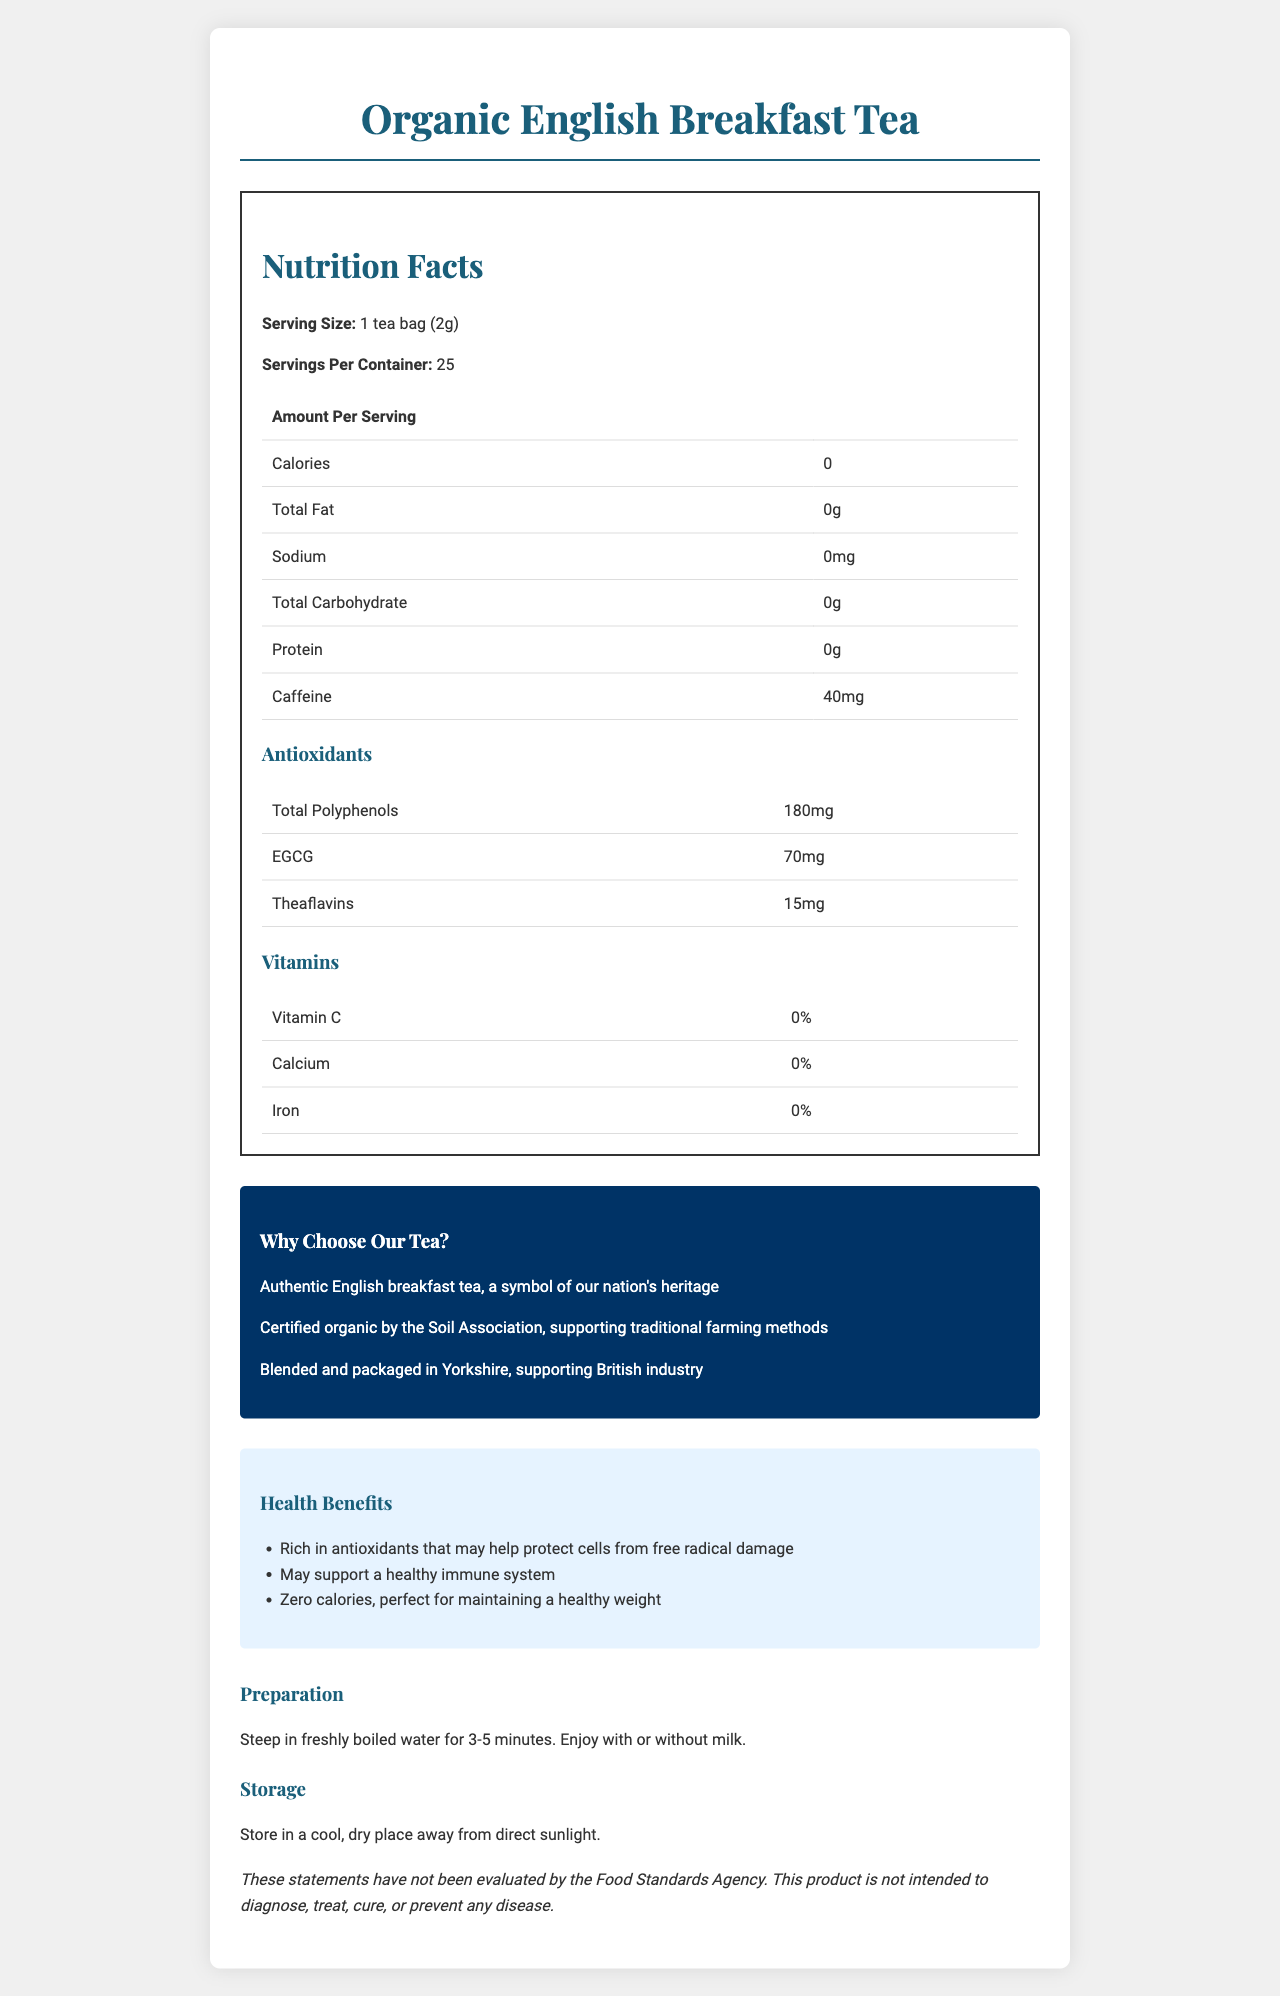what is the serving size for the Organic English Breakfast Tea? The document states that the serving size for the Organic English Breakfast Tea is 1 tea bag (2g).
Answer: 1 tea bag (2g) how many servings are there per container? The document shows that there are 25 servings per container.
Answer: 25 how many calories are there per serving? The nutrition facts panel indicates that each serving has 0 calories.
Answer: 0 what are the antioxidant contents of a serving of this tea? The document lists the antioxidants as Total Polyphenols: 180mg, EGCG: 70mg, Theaflavins: 15mg.
Answer: Total Polyphenols: 180mg, EGCG: 70mg, Theaflavins: 15mg how much caffeine does each serving contain? The document specifies that each serving contains 40mg of caffeine.
Answer: 40mg what is the main ingredient of the Organic English Breakfast Tea? A. Organic black tea leaves from Assam, India B. Green tea leaves C. Herbal blend The document clearly states that the main ingredient is Organic black tea leaves from Assam, India.
Answer: A which vitamin is present in the Organic English Breakfast Tea? A. Vitamin C B. Vitamin D C. Vitamin E D. None The vitamins section in the document indicates that there is 0% Vitamin C, Calcium, and Iron, meaning no vitamins are present.
Answer: D does this tea have any sodium content? The nutrition facts section states that the sodium content is 0mg, which means there is no sodium.
Answer: No why might someone choose this Organic English Breakfast Tea according to the conservative appeal attributes? The conservative appeal section emphasizes British tradition, organic certification by the Soil Association, and local production in Yorkshire as reasons to choose this tea.
Answer: Someone might choose it because it is an authentic symbol of British tradition, is certified organic supporting traditional farming methods, and is blended and packaged in Yorkshire, supporting British industry. what is claimed about the health benefits of this tea? The health claims section lists these three health benefits.
Answer: It is rich in antioxidants that may help protect cells from free radical damage, may support a healthy immune system, and has zero calories which is perfect for maintaining a healthy weight. summarize the main idea of the document. The document contains comprehensive nutrition information, highlights the tea's antioxidant content, underscores its support for British tradition and industry, promotes its health benefits, and gives preparation and storage instructions.
Answer: The document provides detailed information on the nutrition facts, antioxidant properties, ingredients, conservative appeal, health benefits, preparation, and storage instructions for Organic English Breakfast Tea, emphasizing its health benefits and traditional British appeal. where is the calorie information located in the document? The exact location within the document where the calorie information is located is not specified; it's only mentioned in the context of the data itself.
Answer: Cannot be determined what antioxidant content does Organic English Breakfast Tea have? A. 200mg Total Polyphenols B. 180mg EGCG C. 180mg Total Polyphenols D. 90mg Theaflavins The document states that the tea contains 180mg of Total Polyphenols.
Answer: C is the product description evaluated by the Food Standards Agency? The disclaimer section clarifies that the statements have not been evaluated by the Food Standards Agency.
Answer: No 